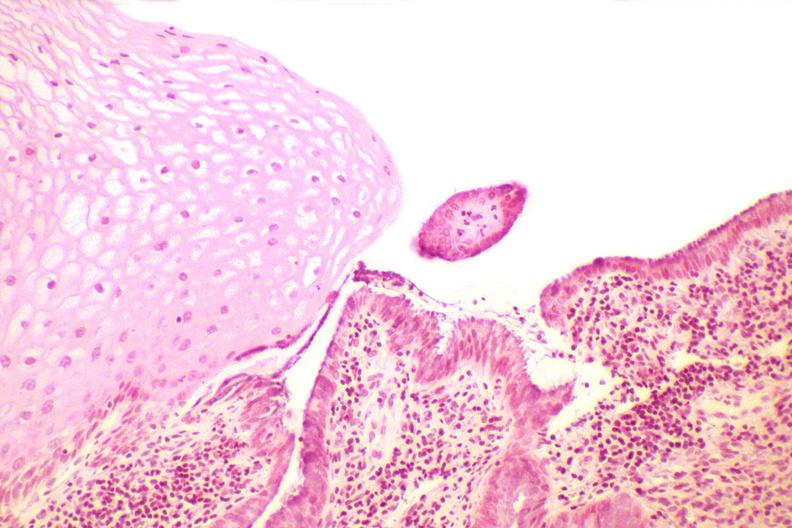where is this from?
Answer the question using a single word or phrase. Female reproductive system 